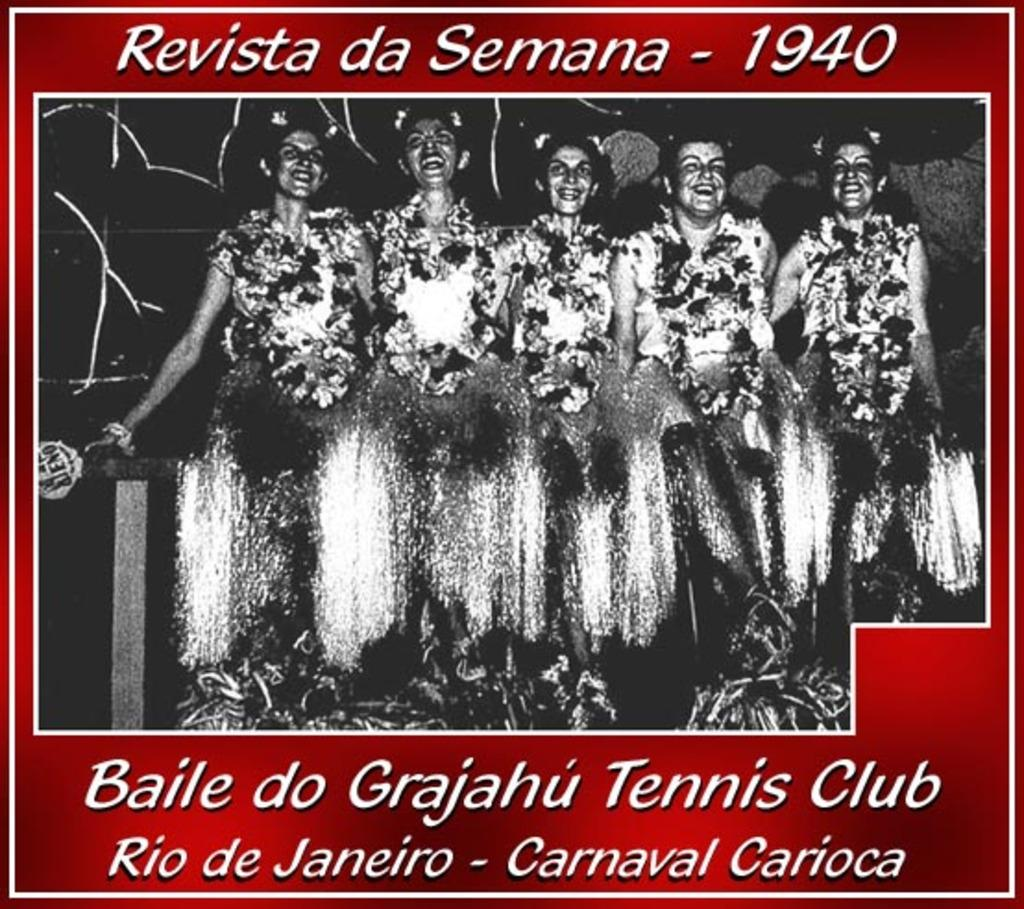What is the main subject of the poster in the image? The main subject of the poster in the image is women. What are the women in the images doing? The women in the images are carrying pom-poms. Is there any text on the poster? Yes, there is text on the poster. Can you tell me how many feathers are on the poster? There are no feathers present on the poster; it features images of women carrying pom-poms. Is there a train visible in the image? There is no train present in the image. 